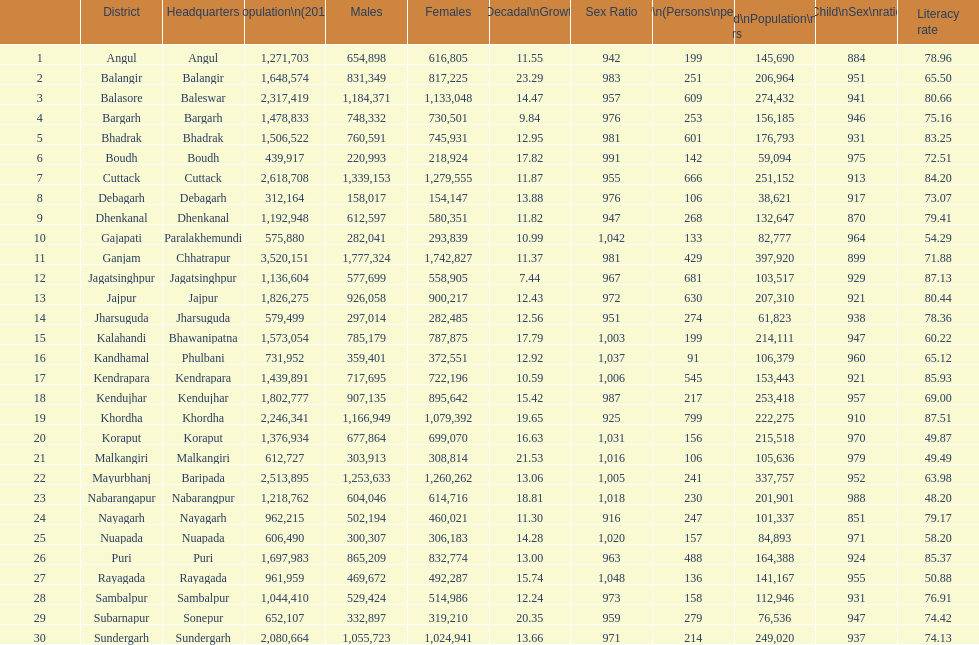Between angul and cuttack districts, which one has a greater population? Cuttack. Give me the full table as a dictionary. {'header': ['', 'District', 'Headquarters', 'Population\\n(2011)', 'Males', 'Females', 'Percentage\\nDecadal\\nGrowth\\n2001-2011', 'Sex Ratio', 'Density\\n(Persons\\nper\\nkm2)', 'Child\\nPopulation\\n0–6 years', 'Child\\nSex\\nratio', 'Literacy rate'], 'rows': [['1', 'Angul', 'Angul', '1,271,703', '654,898', '616,805', '11.55', '942', '199', '145,690', '884', '78.96'], ['2', 'Balangir', 'Balangir', '1,648,574', '831,349', '817,225', '23.29', '983', '251', '206,964', '951', '65.50'], ['3', 'Balasore', 'Baleswar', '2,317,419', '1,184,371', '1,133,048', '14.47', '957', '609', '274,432', '941', '80.66'], ['4', 'Bargarh', 'Bargarh', '1,478,833', '748,332', '730,501', '9.84', '976', '253', '156,185', '946', '75.16'], ['5', 'Bhadrak', 'Bhadrak', '1,506,522', '760,591', '745,931', '12.95', '981', '601', '176,793', '931', '83.25'], ['6', 'Boudh', 'Boudh', '439,917', '220,993', '218,924', '17.82', '991', '142', '59,094', '975', '72.51'], ['7', 'Cuttack', 'Cuttack', '2,618,708', '1,339,153', '1,279,555', '11.87', '955', '666', '251,152', '913', '84.20'], ['8', 'Debagarh', 'Debagarh', '312,164', '158,017', '154,147', '13.88', '976', '106', '38,621', '917', '73.07'], ['9', 'Dhenkanal', 'Dhenkanal', '1,192,948', '612,597', '580,351', '11.82', '947', '268', '132,647', '870', '79.41'], ['10', 'Gajapati', 'Paralakhemundi', '575,880', '282,041', '293,839', '10.99', '1,042', '133', '82,777', '964', '54.29'], ['11', 'Ganjam', 'Chhatrapur', '3,520,151', '1,777,324', '1,742,827', '11.37', '981', '429', '397,920', '899', '71.88'], ['12', 'Jagatsinghpur', 'Jagatsinghpur', '1,136,604', '577,699', '558,905', '7.44', '967', '681', '103,517', '929', '87.13'], ['13', 'Jajpur', 'Jajpur', '1,826,275', '926,058', '900,217', '12.43', '972', '630', '207,310', '921', '80.44'], ['14', 'Jharsuguda', 'Jharsuguda', '579,499', '297,014', '282,485', '12.56', '951', '274', '61,823', '938', '78.36'], ['15', 'Kalahandi', 'Bhawanipatna', '1,573,054', '785,179', '787,875', '17.79', '1,003', '199', '214,111', '947', '60.22'], ['16', 'Kandhamal', 'Phulbani', '731,952', '359,401', '372,551', '12.92', '1,037', '91', '106,379', '960', '65.12'], ['17', 'Kendrapara', 'Kendrapara', '1,439,891', '717,695', '722,196', '10.59', '1,006', '545', '153,443', '921', '85.93'], ['18', 'Kendujhar', 'Kendujhar', '1,802,777', '907,135', '895,642', '15.42', '987', '217', '253,418', '957', '69.00'], ['19', 'Khordha', 'Khordha', '2,246,341', '1,166,949', '1,079,392', '19.65', '925', '799', '222,275', '910', '87.51'], ['20', 'Koraput', 'Koraput', '1,376,934', '677,864', '699,070', '16.63', '1,031', '156', '215,518', '970', '49.87'], ['21', 'Malkangiri', 'Malkangiri', '612,727', '303,913', '308,814', '21.53', '1,016', '106', '105,636', '979', '49.49'], ['22', 'Mayurbhanj', 'Baripada', '2,513,895', '1,253,633', '1,260,262', '13.06', '1,005', '241', '337,757', '952', '63.98'], ['23', 'Nabarangapur', 'Nabarangpur', '1,218,762', '604,046', '614,716', '18.81', '1,018', '230', '201,901', '988', '48.20'], ['24', 'Nayagarh', 'Nayagarh', '962,215', '502,194', '460,021', '11.30', '916', '247', '101,337', '851', '79.17'], ['25', 'Nuapada', 'Nuapada', '606,490', '300,307', '306,183', '14.28', '1,020', '157', '84,893', '971', '58.20'], ['26', 'Puri', 'Puri', '1,697,983', '865,209', '832,774', '13.00', '963', '488', '164,388', '924', '85.37'], ['27', 'Rayagada', 'Rayagada', '961,959', '469,672', '492,287', '15.74', '1,048', '136', '141,167', '955', '50.88'], ['28', 'Sambalpur', 'Sambalpur', '1,044,410', '529,424', '514,986', '12.24', '973', '158', '112,946', '931', '76.91'], ['29', 'Subarnapur', 'Sonepur', '652,107', '332,897', '319,210', '20.35', '959', '279', '76,536', '947', '74.42'], ['30', 'Sundergarh', 'Sundergarh', '2,080,664', '1,055,723', '1,024,941', '13.66', '971', '214', '249,020', '937', '74.13']]} 